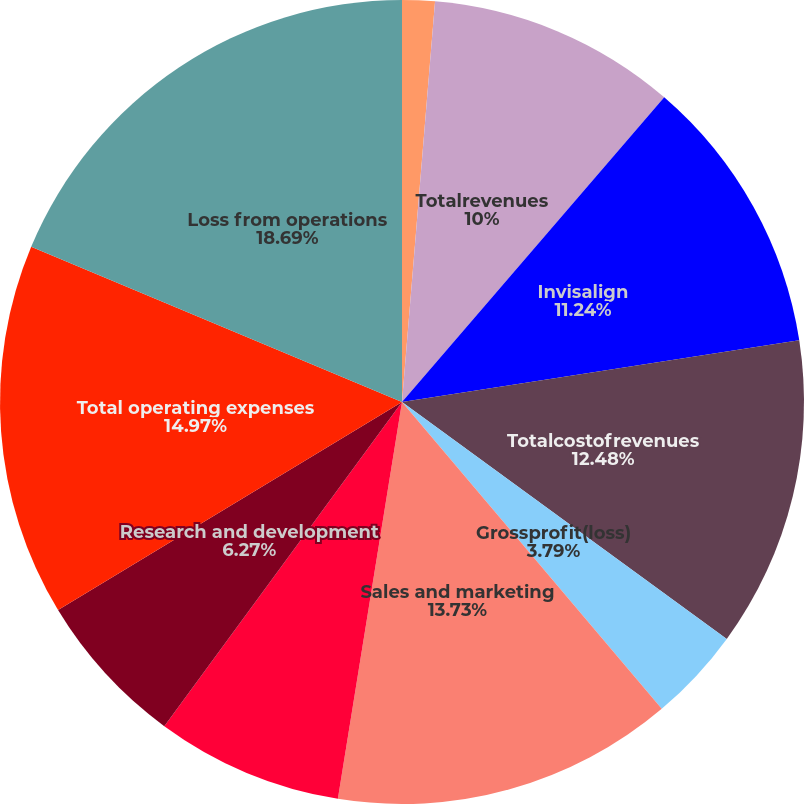Convert chart. <chart><loc_0><loc_0><loc_500><loc_500><pie_chart><fcel>Ancillary products and other<fcel>Totalrevenues<fcel>Invisalign<fcel>Totalcostofrevenues<fcel>Grossprofit(loss)<fcel>Sales and marketing<fcel>General and administrative<fcel>Research and development<fcel>Total operating expenses<fcel>Loss from operations<nl><fcel>1.31%<fcel>10.0%<fcel>11.24%<fcel>12.48%<fcel>3.79%<fcel>13.73%<fcel>7.52%<fcel>6.27%<fcel>14.97%<fcel>18.69%<nl></chart> 